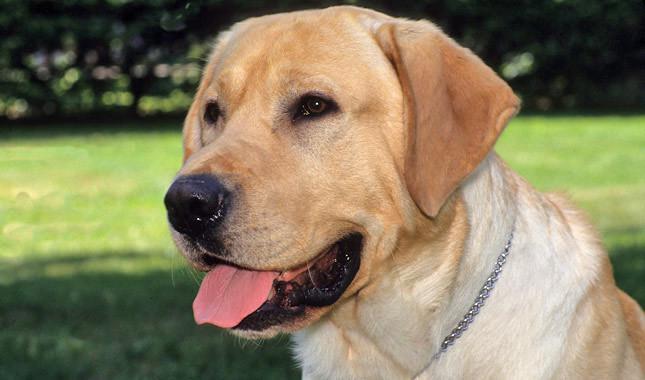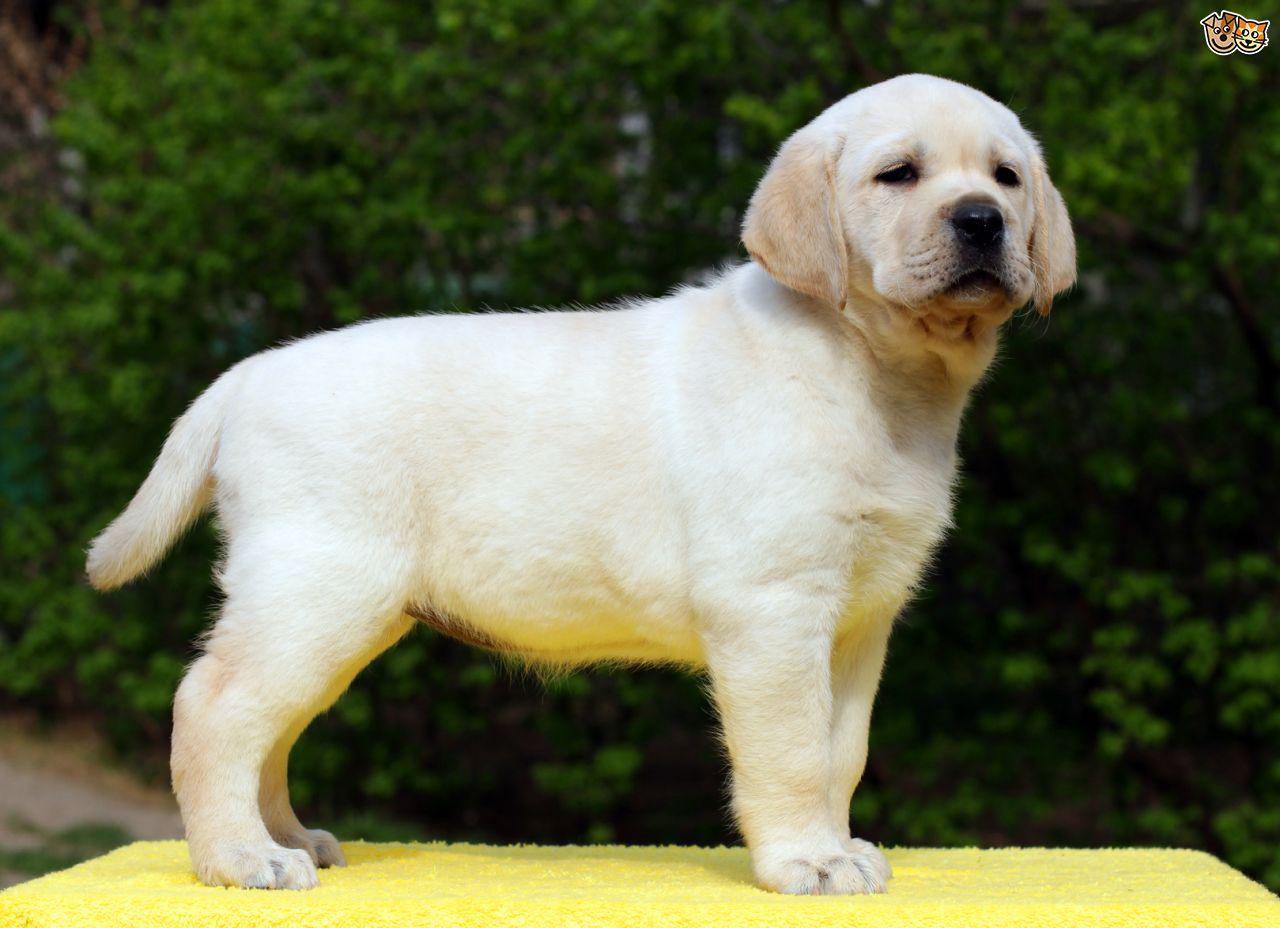The first image is the image on the left, the second image is the image on the right. For the images displayed, is the sentence "Images show foreground dogs in profile on grass with bodies in opposite directions." factually correct? Answer yes or no. No. 